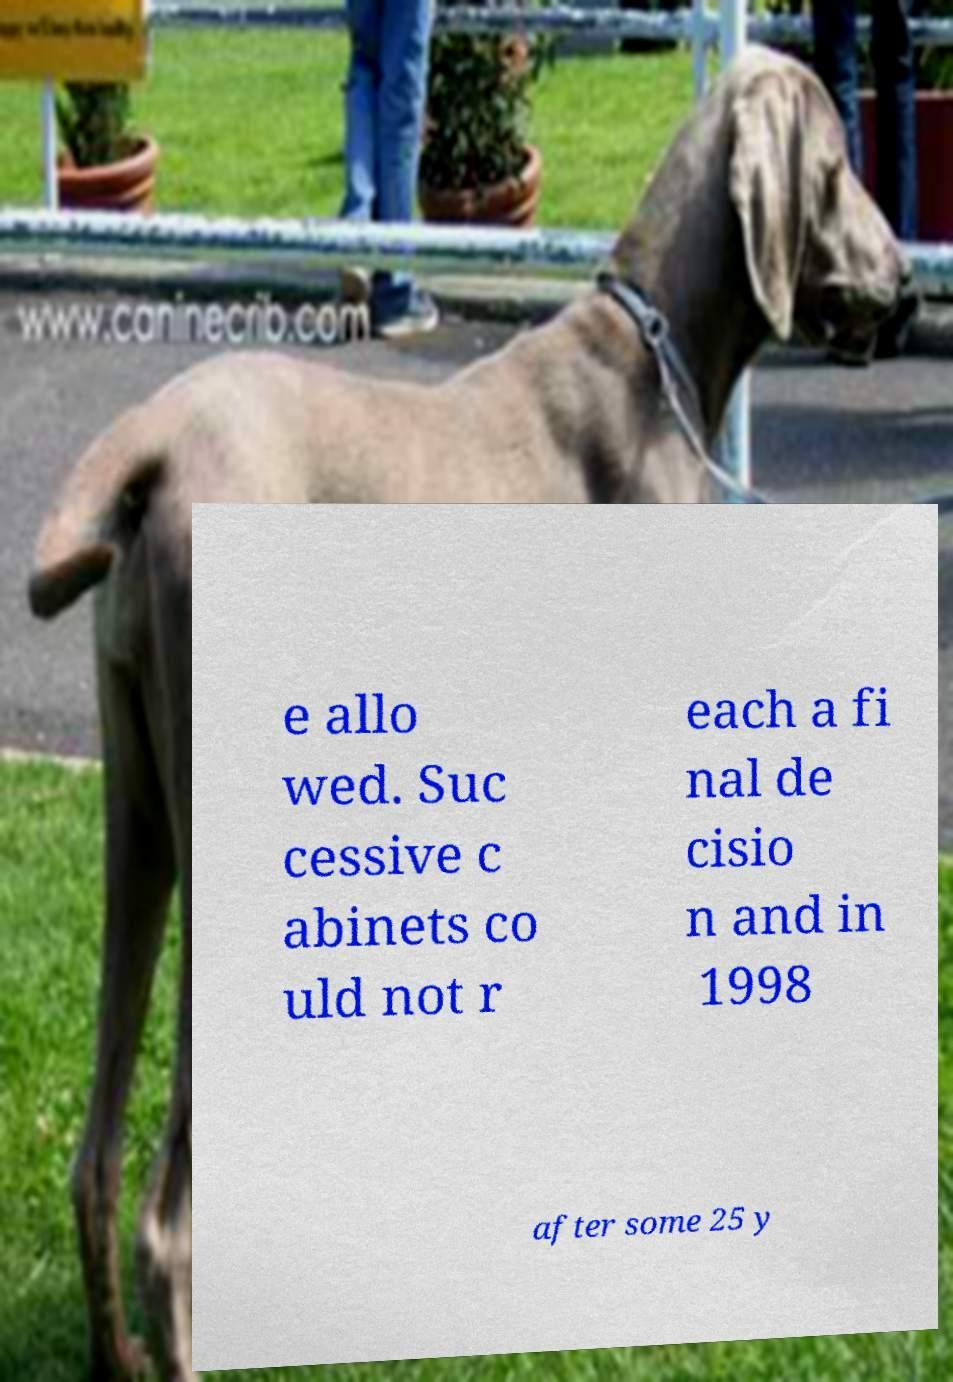There's text embedded in this image that I need extracted. Can you transcribe it verbatim? e allo wed. Suc cessive c abinets co uld not r each a fi nal de cisio n and in 1998 after some 25 y 